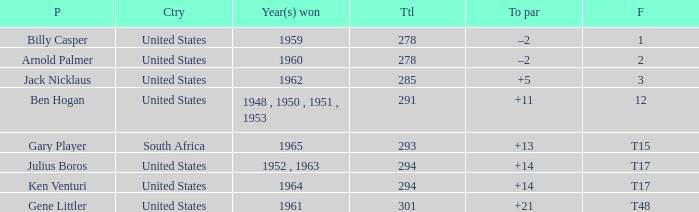What is Finish, when Country is "United States", and when Player is "Julius Boros"? T17. 